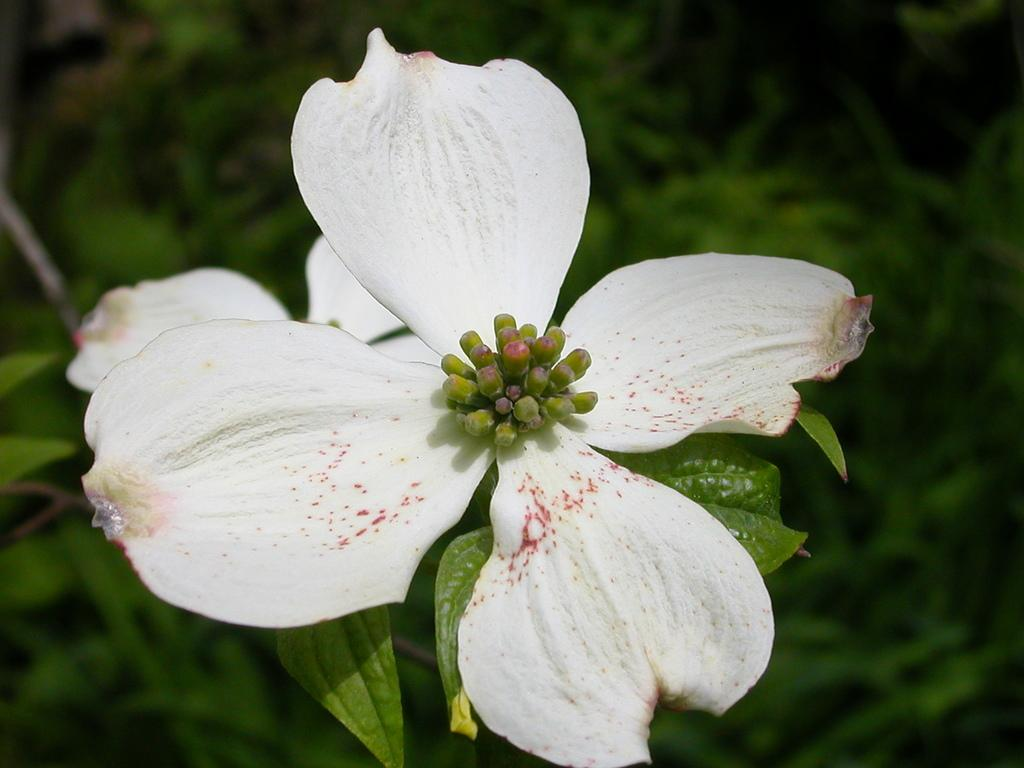What type of flower is in the image? There is a white flower in the image. What color are the leaves in the image? There are green leaves in the image. Can you describe the background of the image? The background of the image appears blurry. What type of lock is used to secure the comb in the image? There is no lock or comb present in the image; it features a white flower and green leaves. 